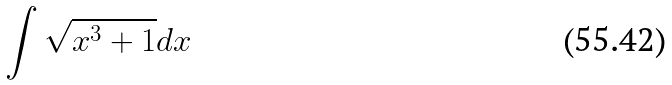Convert formula to latex. <formula><loc_0><loc_0><loc_500><loc_500>\int \sqrt { x ^ { 3 } + 1 } d x</formula> 